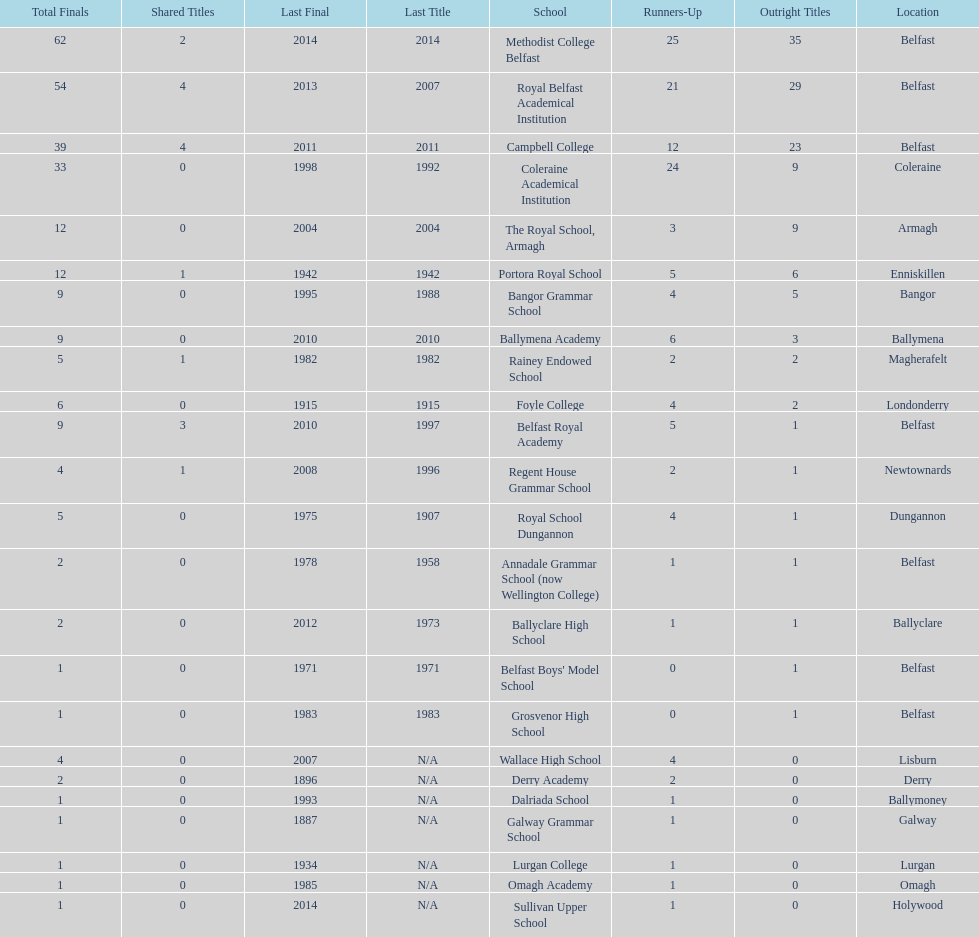Parse the table in full. {'header': ['Total Finals', 'Shared Titles', 'Last Final', 'Last Title', 'School', 'Runners-Up', 'Outright Titles', 'Location'], 'rows': [['62', '2', '2014', '2014', 'Methodist College Belfast', '25', '35', 'Belfast'], ['54', '4', '2013', '2007', 'Royal Belfast Academical Institution', '21', '29', 'Belfast'], ['39', '4', '2011', '2011', 'Campbell College', '12', '23', 'Belfast'], ['33', '0', '1998', '1992', 'Coleraine Academical Institution', '24', '9', 'Coleraine'], ['12', '0', '2004', '2004', 'The Royal School, Armagh', '3', '9', 'Armagh'], ['12', '1', '1942', '1942', 'Portora Royal School', '5', '6', 'Enniskillen'], ['9', '0', '1995', '1988', 'Bangor Grammar School', '4', '5', 'Bangor'], ['9', '0', '2010', '2010', 'Ballymena Academy', '6', '3', 'Ballymena'], ['5', '1', '1982', '1982', 'Rainey Endowed School', '2', '2', 'Magherafelt'], ['6', '0', '1915', '1915', 'Foyle College', '4', '2', 'Londonderry'], ['9', '3', '2010', '1997', 'Belfast Royal Academy', '5', '1', 'Belfast'], ['4', '1', '2008', '1996', 'Regent House Grammar School', '2', '1', 'Newtownards'], ['5', '0', '1975', '1907', 'Royal School Dungannon', '4', '1', 'Dungannon'], ['2', '0', '1978', '1958', 'Annadale Grammar School (now Wellington College)', '1', '1', 'Belfast'], ['2', '0', '2012', '1973', 'Ballyclare High School', '1', '1', 'Ballyclare'], ['1', '0', '1971', '1971', "Belfast Boys' Model School", '0', '1', 'Belfast'], ['1', '0', '1983', '1983', 'Grosvenor High School', '0', '1', 'Belfast'], ['4', '0', '2007', 'N/A', 'Wallace High School', '4', '0', 'Lisburn'], ['2', '0', '1896', 'N/A', 'Derry Academy', '2', '0', 'Derry'], ['1', '0', '1993', 'N/A', 'Dalriada School', '1', '0', 'Ballymoney'], ['1', '0', '1887', 'N/A', 'Galway Grammar School', '1', '0', 'Galway'], ['1', '0', '1934', 'N/A', 'Lurgan College', '1', '0', 'Lurgan'], ['1', '0', '1985', 'N/A', 'Omagh Academy', '1', '0', 'Omagh'], ['1', '0', '2014', 'N/A', 'Sullivan Upper School', '1', '0', 'Holywood']]} What is the difference in runners-up from coleraine academical institution and royal school dungannon? 20. 